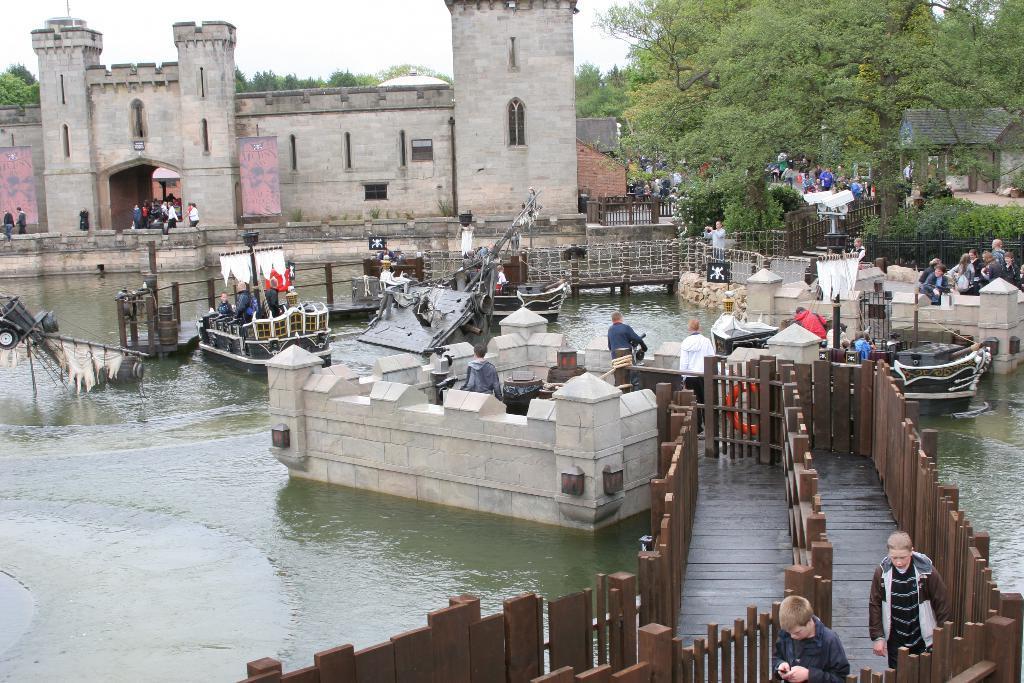In one or two sentences, can you explain what this image depicts? In this image we can see the water. On the water we can see bridges and boats. On the bridges we can see the wooden fencing and persons and there are few people on the boats. On the right, there are plants, trees, houses and metal fencing. Behind the water we can see a building and persons. Behind the building we can see the trees. At the top we can see the sky. 